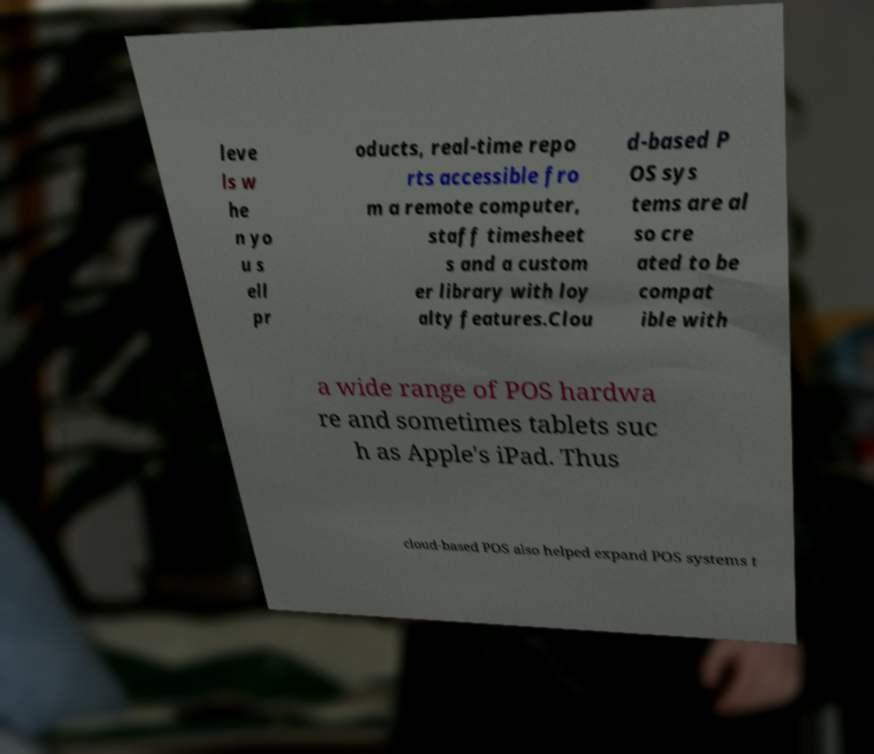Please read and relay the text visible in this image. What does it say? leve ls w he n yo u s ell pr oducts, real-time repo rts accessible fro m a remote computer, staff timesheet s and a custom er library with loy alty features.Clou d-based P OS sys tems are al so cre ated to be compat ible with a wide range of POS hardwa re and sometimes tablets suc h as Apple's iPad. Thus cloud-based POS also helped expand POS systems t 